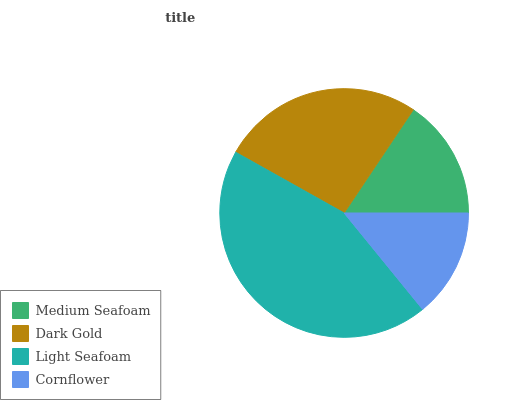Is Cornflower the minimum?
Answer yes or no. Yes. Is Light Seafoam the maximum?
Answer yes or no. Yes. Is Dark Gold the minimum?
Answer yes or no. No. Is Dark Gold the maximum?
Answer yes or no. No. Is Dark Gold greater than Medium Seafoam?
Answer yes or no. Yes. Is Medium Seafoam less than Dark Gold?
Answer yes or no. Yes. Is Medium Seafoam greater than Dark Gold?
Answer yes or no. No. Is Dark Gold less than Medium Seafoam?
Answer yes or no. No. Is Dark Gold the high median?
Answer yes or no. Yes. Is Medium Seafoam the low median?
Answer yes or no. Yes. Is Light Seafoam the high median?
Answer yes or no. No. Is Dark Gold the low median?
Answer yes or no. No. 